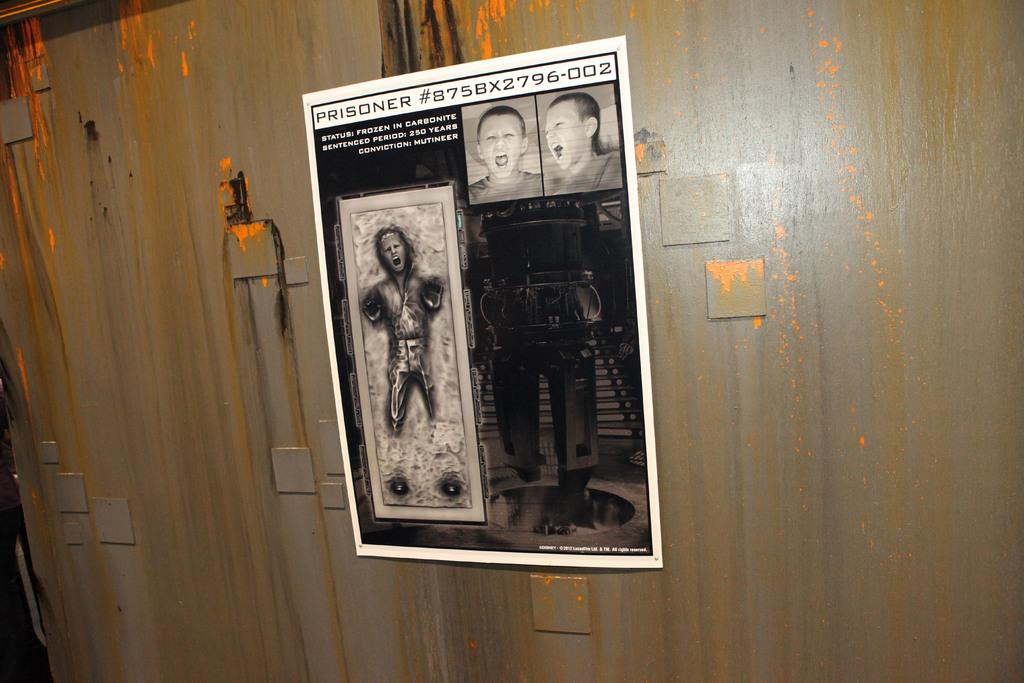What is featured on the poster in the image? The poster has an image and text. Can you describe the image on the poster? Unfortunately, the specific image on the poster cannot be determined from the provided facts. What is the poster attached to in the image? The poster is on a wooden wall. What type of beef is being sold at the market in the image? There is no market or beef present in the image; it features a poster on a wooden wall. Can you tell me how many rifles are depicted on the poster? There is no rifle present on the poster; it only has an image and text. 